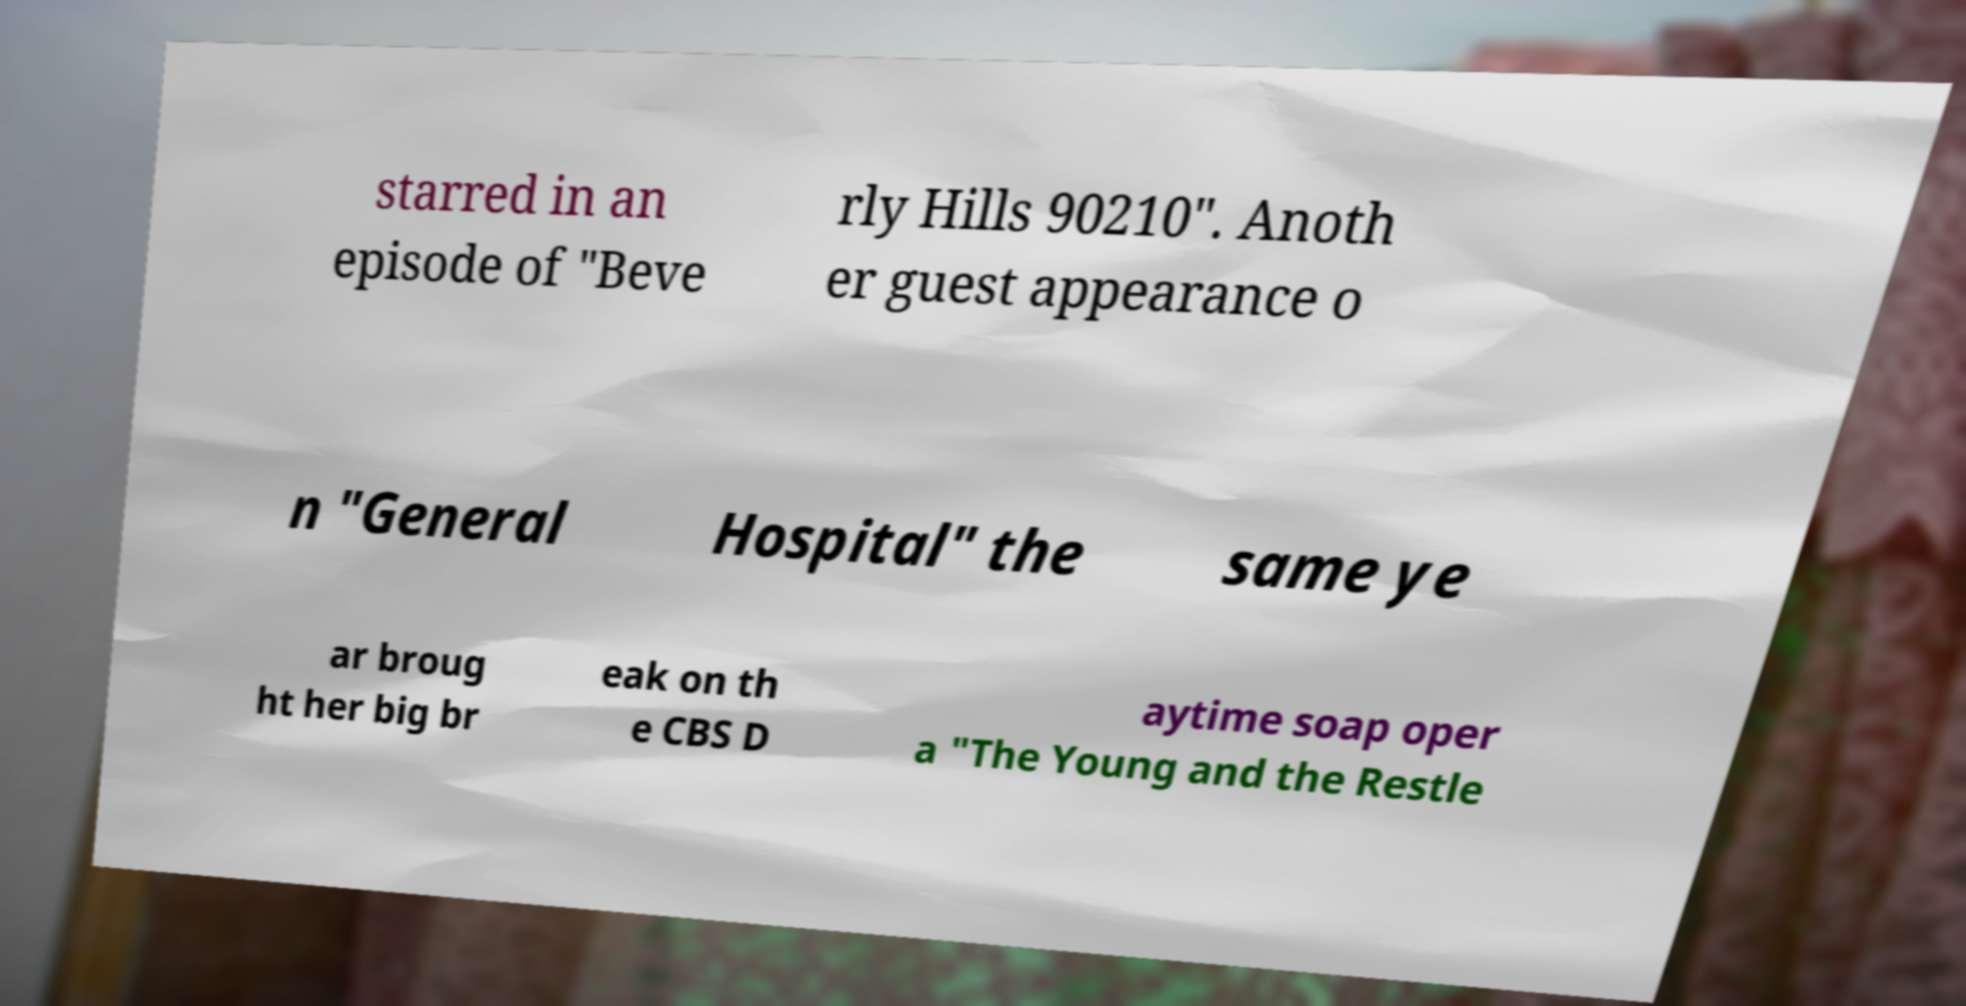I need the written content from this picture converted into text. Can you do that? starred in an episode of "Beve rly Hills 90210". Anoth er guest appearance o n "General Hospital" the same ye ar broug ht her big br eak on th e CBS D aytime soap oper a "The Young and the Restle 